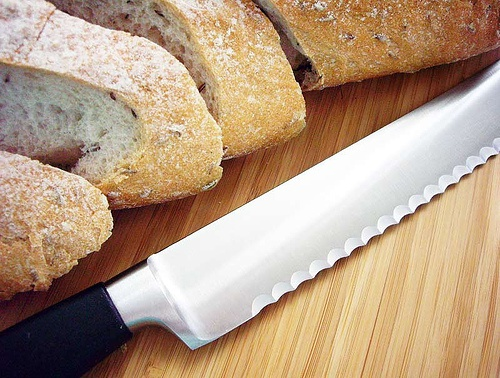Describe the objects in this image and their specific colors. I can see dining table in lightgray, tan, and maroon tones, knife in lightgray, white, black, darkgray, and maroon tones, sandwich in lightgray, brown, tan, and gray tones, and sandwich in lightgray, tan, and gray tones in this image. 